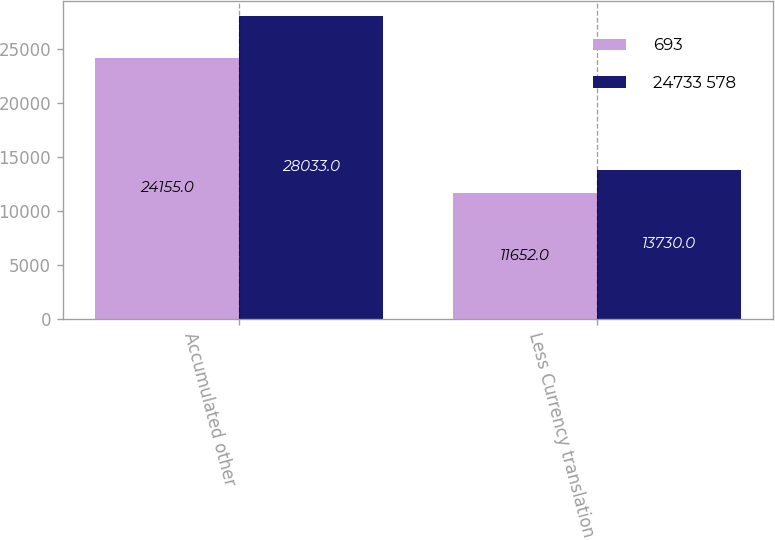<chart> <loc_0><loc_0><loc_500><loc_500><stacked_bar_chart><ecel><fcel>Accumulated other<fcel>Less Currency translation<nl><fcel>693<fcel>24155<fcel>11652<nl><fcel>24733 578<fcel>28033<fcel>13730<nl></chart> 